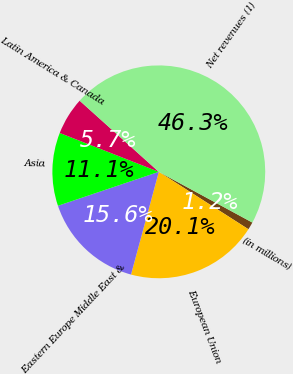<chart> <loc_0><loc_0><loc_500><loc_500><pie_chart><fcel>(in millions)<fcel>European Union<fcel>Eastern Europe Middle East &<fcel>Asia<fcel>Latin America & Canada<fcel>Net revenues (1)<nl><fcel>1.16%<fcel>20.14%<fcel>15.63%<fcel>11.12%<fcel>5.7%<fcel>46.26%<nl></chart> 